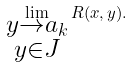Convert formula to latex. <formula><loc_0><loc_0><loc_500><loc_500>\lim _ { \substack { y \to a _ { k } \\ y \in J } } R ( x , y ) .</formula> 